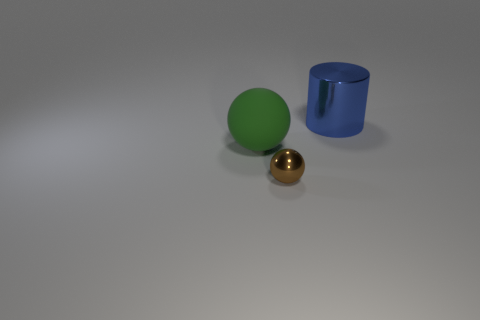Subtract all red balls. Subtract all brown cylinders. How many balls are left? 2 Add 3 small balls. How many objects exist? 6 Subtract all spheres. How many objects are left? 1 Add 1 large green matte objects. How many large green matte objects exist? 2 Subtract 0 gray cylinders. How many objects are left? 3 Subtract all blue shiny cylinders. Subtract all metallic cylinders. How many objects are left? 1 Add 1 metallic balls. How many metallic balls are left? 2 